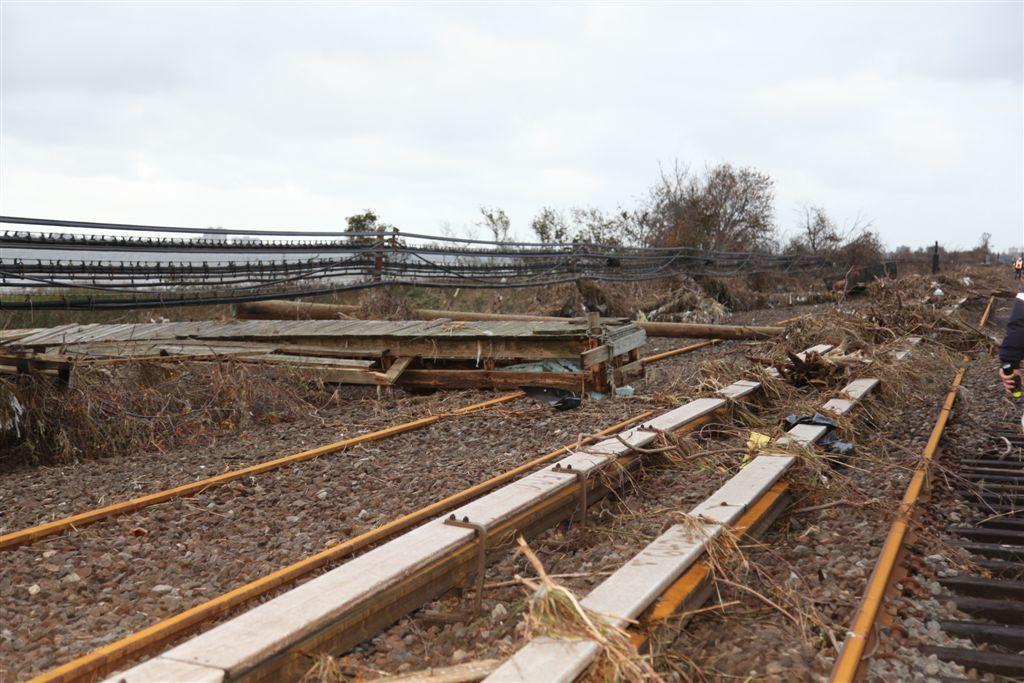In one or two sentences, can you explain what this image depicts? There is a railway track at the bottom of this image. There is a fencing and some trees are present in the background. There is a sky at the top of this image. 